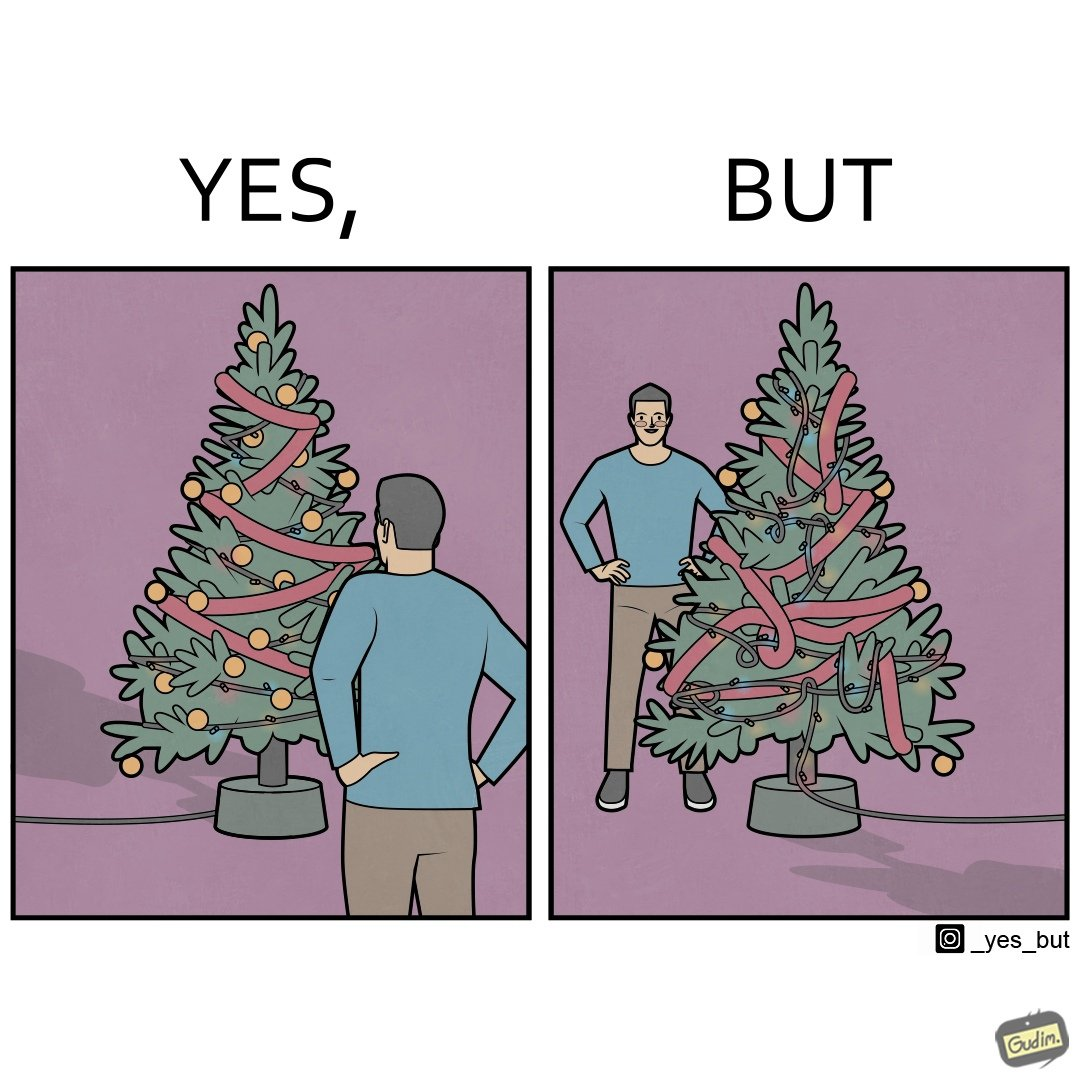Why is this image considered satirical? The image is ironic, because in the first image a person is seen watching his decorated X-mas tree but in the second image it is shown that the tree is looking beautiful not due to its natural beauty but the bulbs connected via power decorated over it 